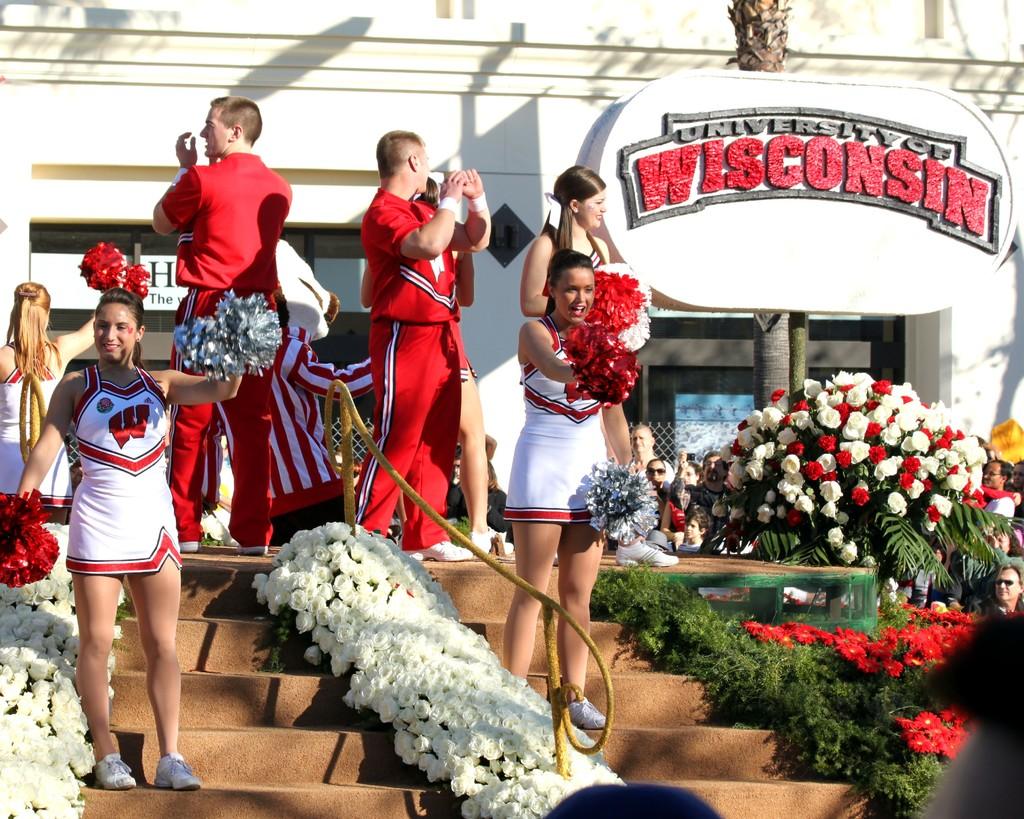Where is this likely located at?
Provide a short and direct response. Wisconsin. What college is shown on the sign?
Your answer should be very brief. University of wisconsin. 